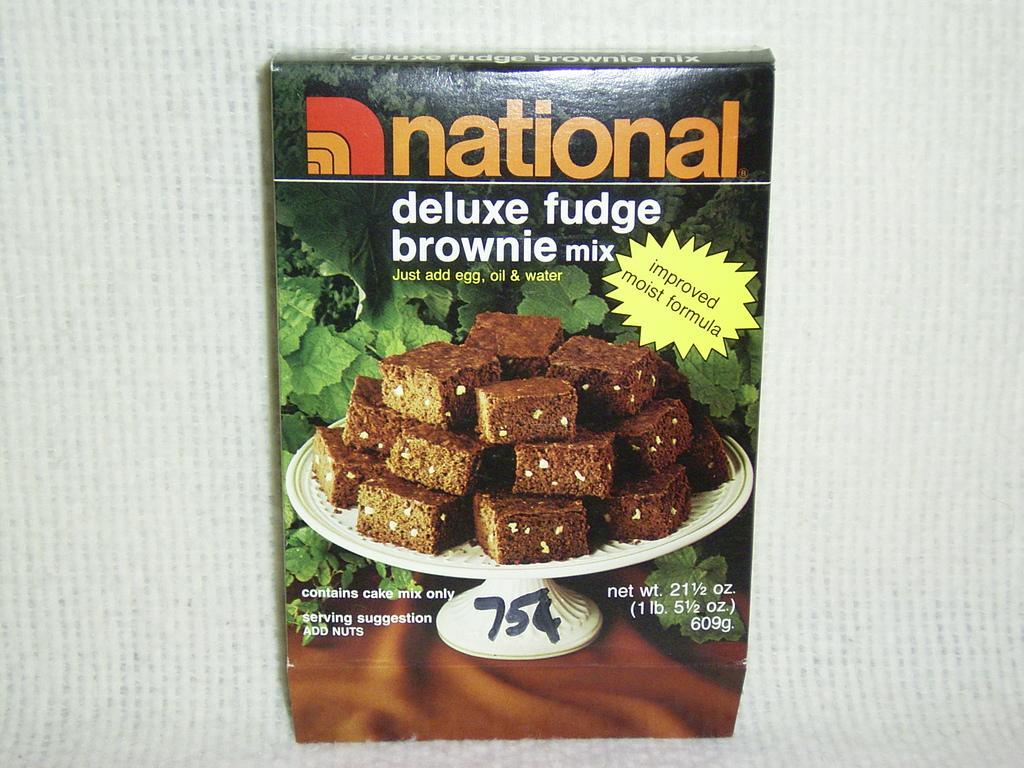Could you give a brief overview of what you see in this image? It is a zoom in picture of a brownie mix box placed on the white surface. 